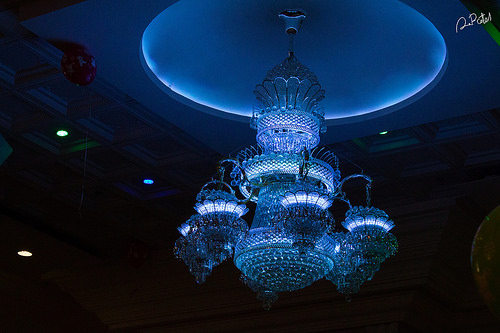<image>
Can you confirm if the spotlight is on the ceiling? Yes. Looking at the image, I can see the spotlight is positioned on top of the ceiling, with the ceiling providing support. 